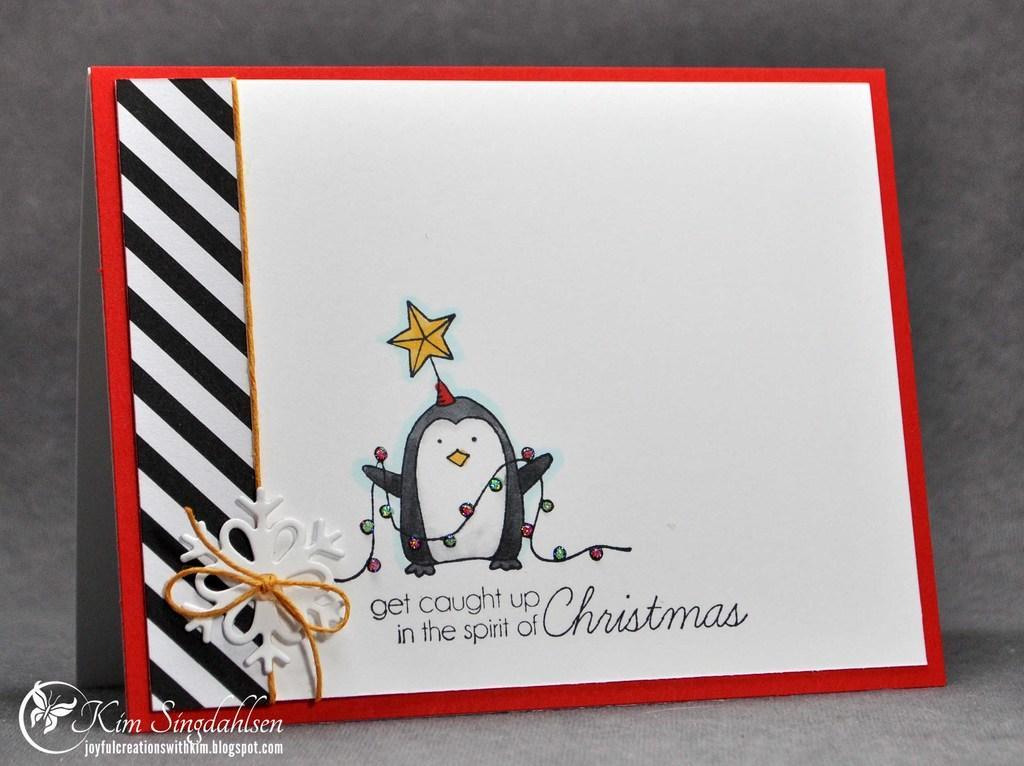Please provide a concise description of this image. In this image there is a card on that card there is some text and a picture, in the bottom left there is some text, in the background there is a wall. 